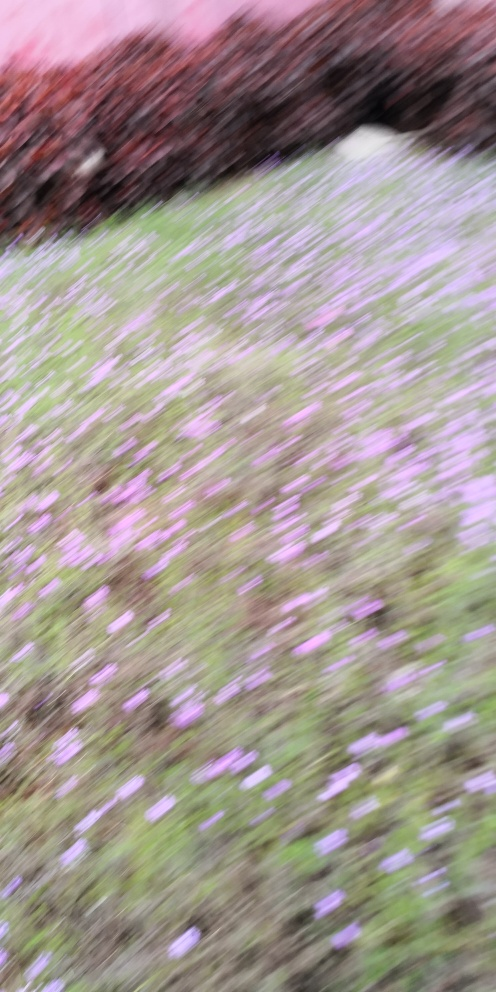What could have caused the blurriness in this image? The blurriness could be due to a quick movement of the camera or the subject during the shot, or it could have been taken with a slow shutter speed in a vibratory environment. Is there anything in the image that can be identified despite the poor quality? It is challenging to make out specifics, but there appears to be a field of flowers, possibly purple in color, which suggests an outdoor setting, perhaps a garden or park. 